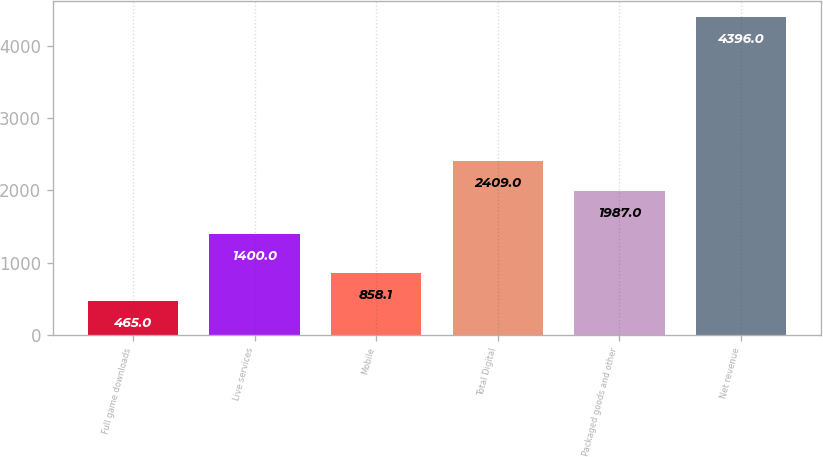Convert chart to OTSL. <chart><loc_0><loc_0><loc_500><loc_500><bar_chart><fcel>Full game downloads<fcel>Live services<fcel>Mobile<fcel>Total Digital<fcel>Packaged goods and other<fcel>Net revenue<nl><fcel>465<fcel>1400<fcel>858.1<fcel>2409<fcel>1987<fcel>4396<nl></chart> 